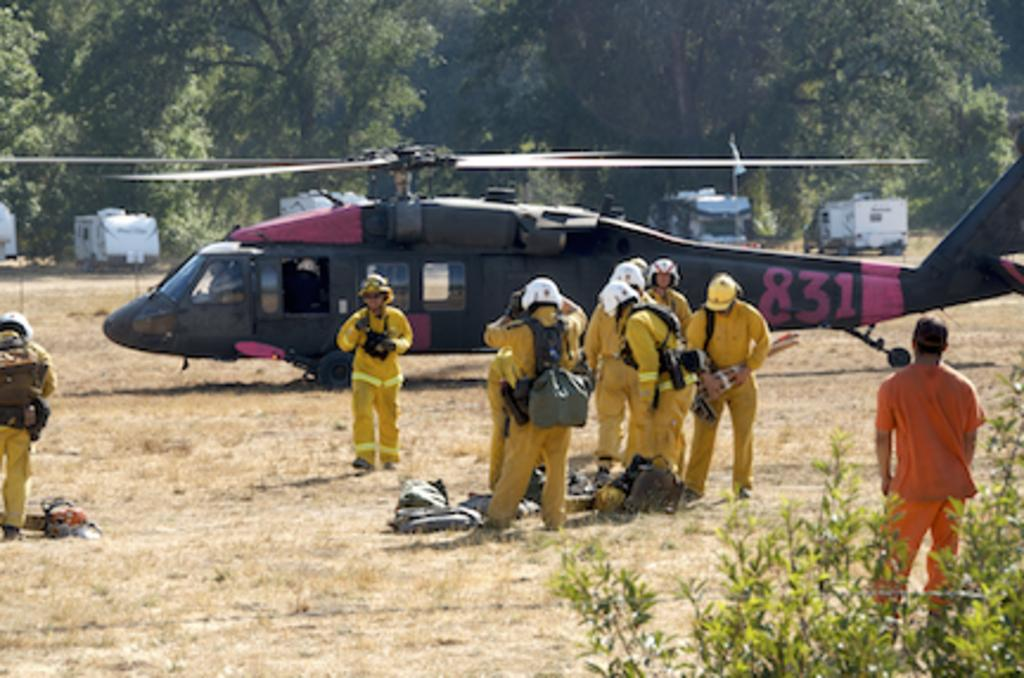<image>
Write a terse but informative summary of the picture. Red and black helicopter with a red number 831. 